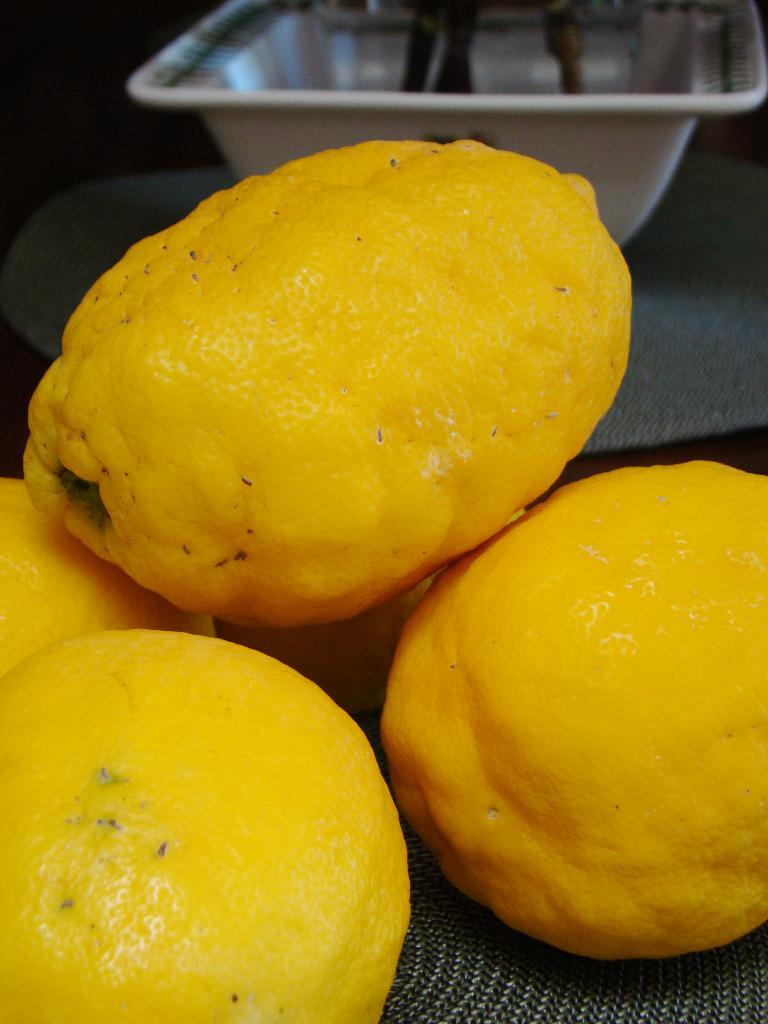What type of food can be seen in the image? There are fruits in the image. Can you describe the container in the background of the image? Unfortunately, the facts provided do not give any details about the container, so we cannot describe it. How far away is the van from the fruits in the image? There is no van present in the image, so we cannot determine the distance between the fruits and a van. 